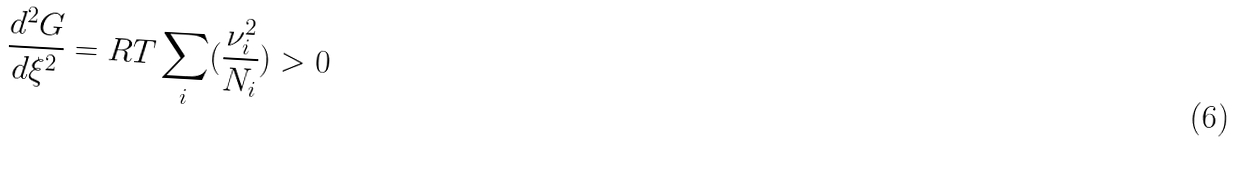Convert formula to latex. <formula><loc_0><loc_0><loc_500><loc_500>\frac { d ^ { 2 } G } { d \xi ^ { 2 } } = R T \sum _ { i } ( \frac { \nu ^ { 2 } _ { i } } { N _ { i } } ) > 0</formula> 